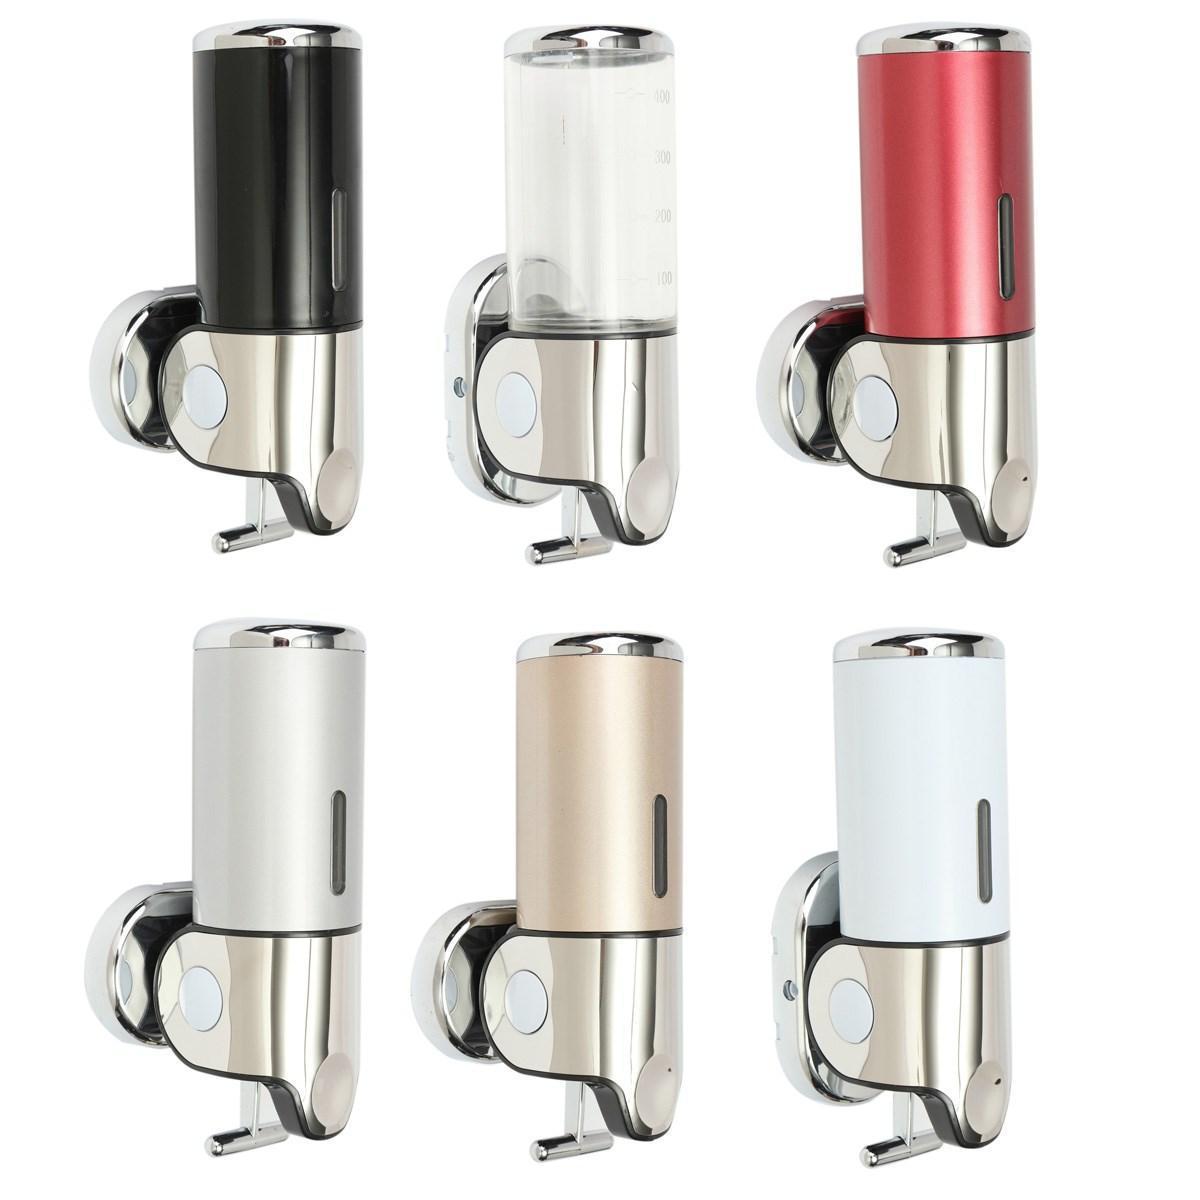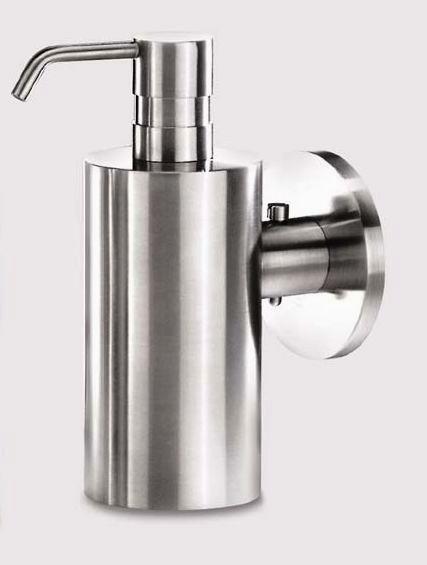The first image is the image on the left, the second image is the image on the right. For the images displayed, is the sentence "The dispenser in the image on the right has a round mounting bracket." factually correct? Answer yes or no. Yes. 